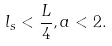<formula> <loc_0><loc_0><loc_500><loc_500>l _ { s } < \frac { L } { 4 } , a < 2 .</formula> 